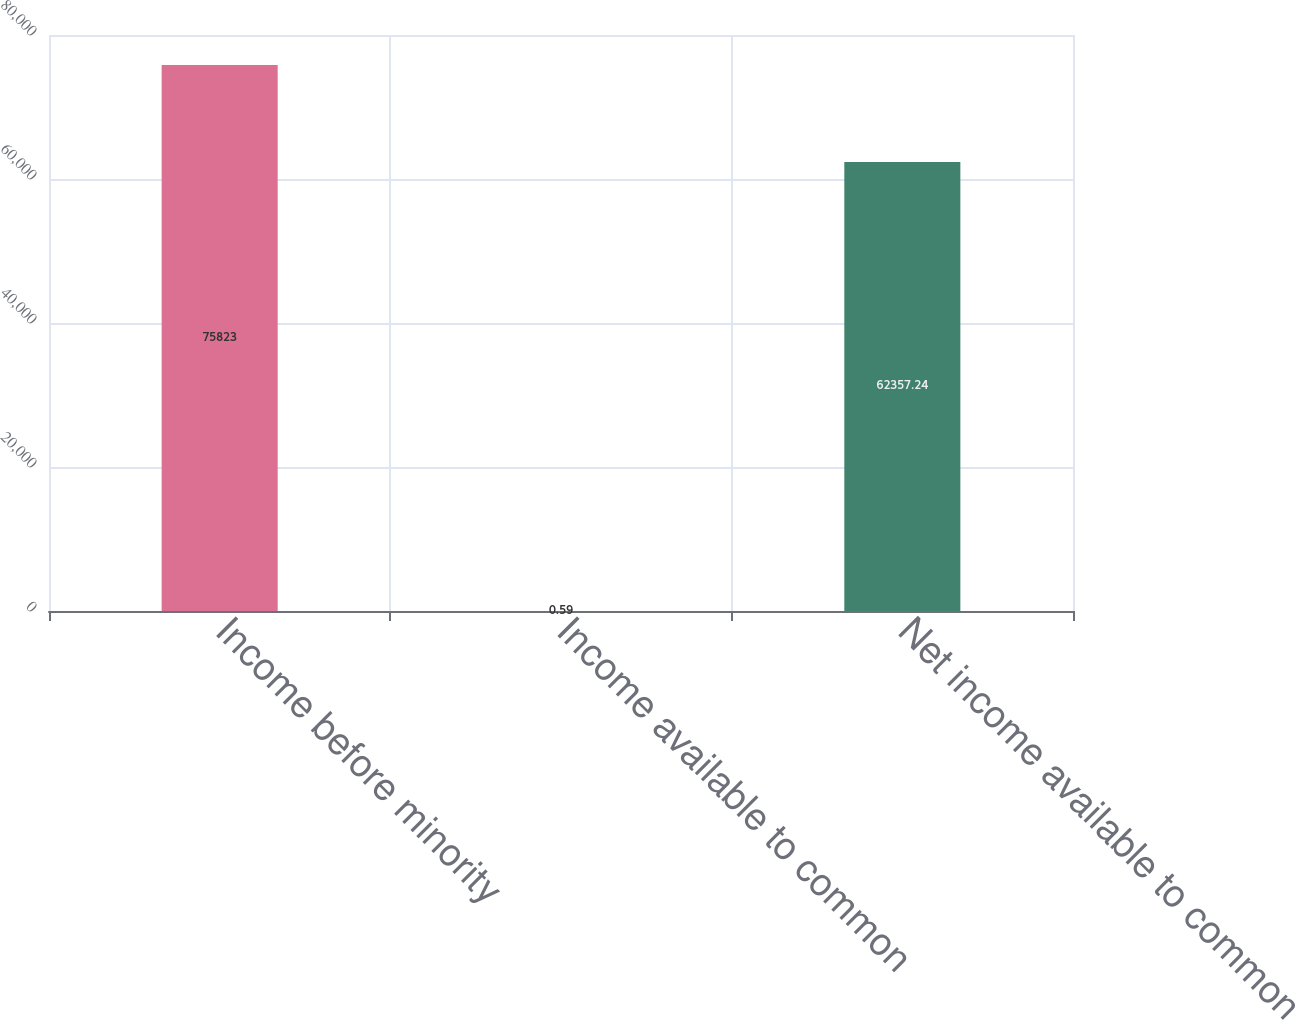Convert chart to OTSL. <chart><loc_0><loc_0><loc_500><loc_500><bar_chart><fcel>Income before minority<fcel>Income available to common<fcel>Net income available to common<nl><fcel>75823<fcel>0.59<fcel>62357.2<nl></chart> 